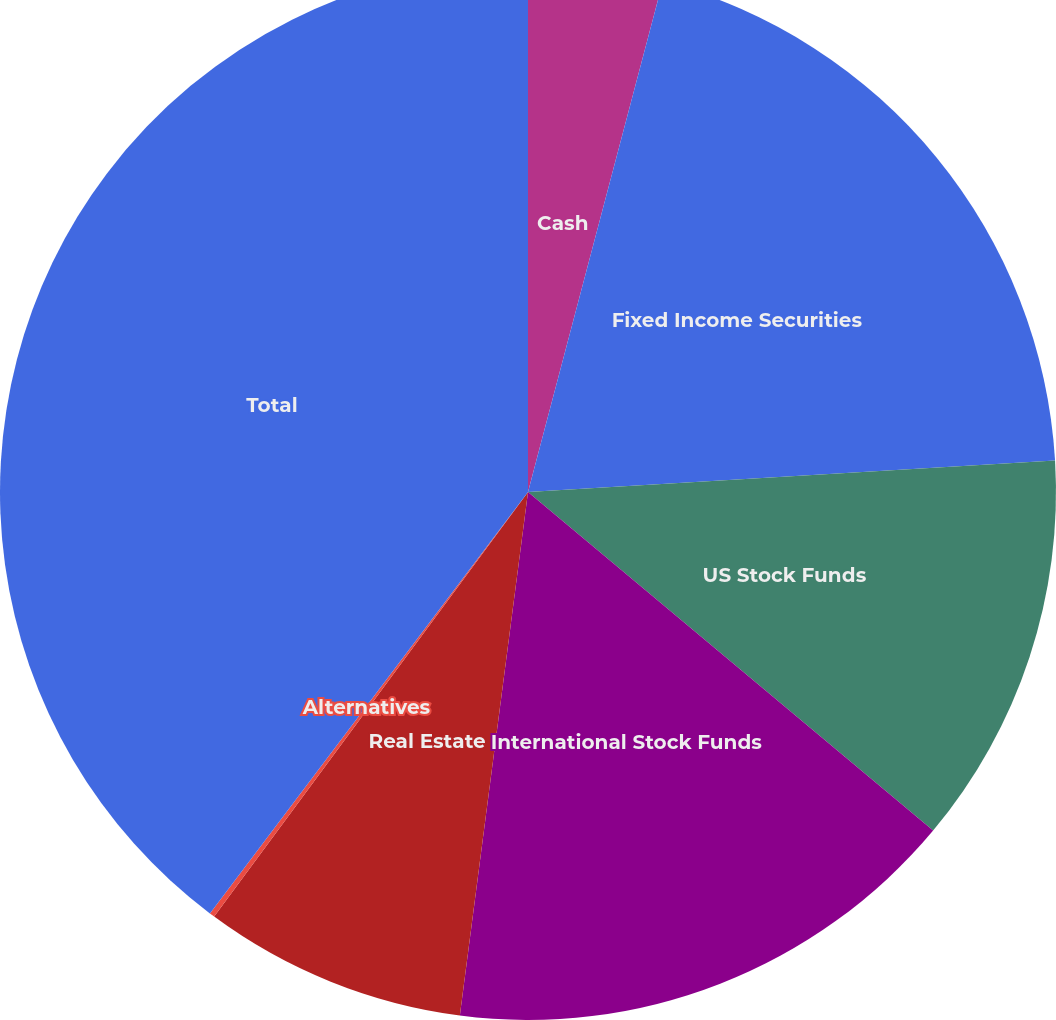<chart> <loc_0><loc_0><loc_500><loc_500><pie_chart><fcel>Cash<fcel>Fixed Income Securities<fcel>US Stock Funds<fcel>International Stock Funds<fcel>Real Estate<fcel>Alternatives<fcel>Total<nl><fcel>4.11%<fcel>19.94%<fcel>12.03%<fcel>15.98%<fcel>8.07%<fcel>0.16%<fcel>39.71%<nl></chart> 